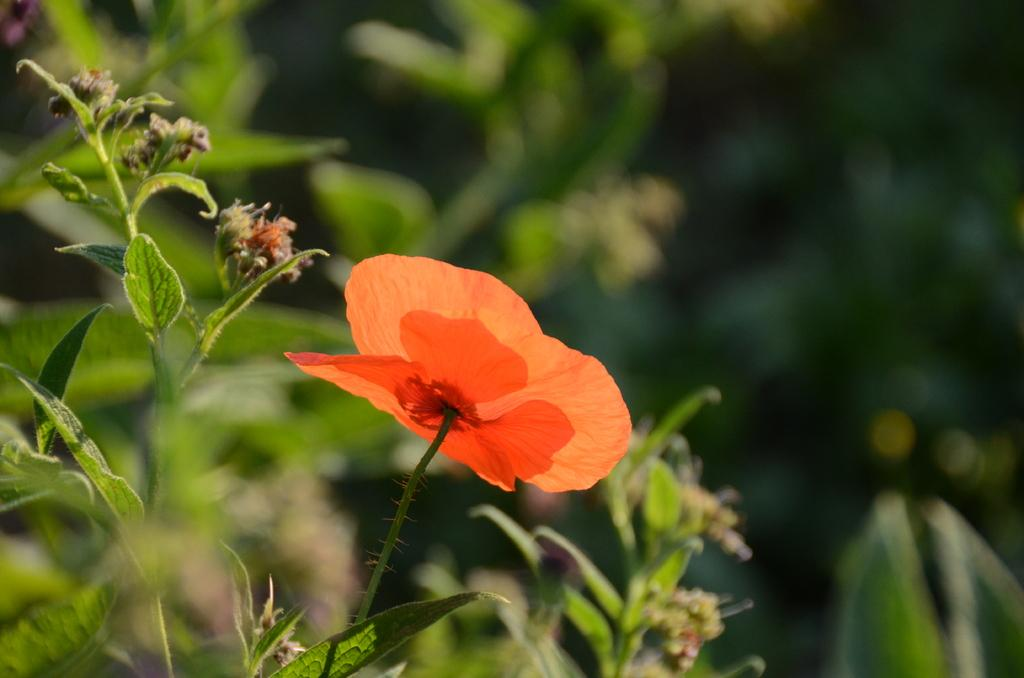What is the main subject of the image? There is a flower on a plant in the image. Can you describe the background of the image? The background of the image is blurred. How many boys can be seen playing on the coast in the image? There are no boys or coast present in the image; it features a flower on a plant with a blurred background. 